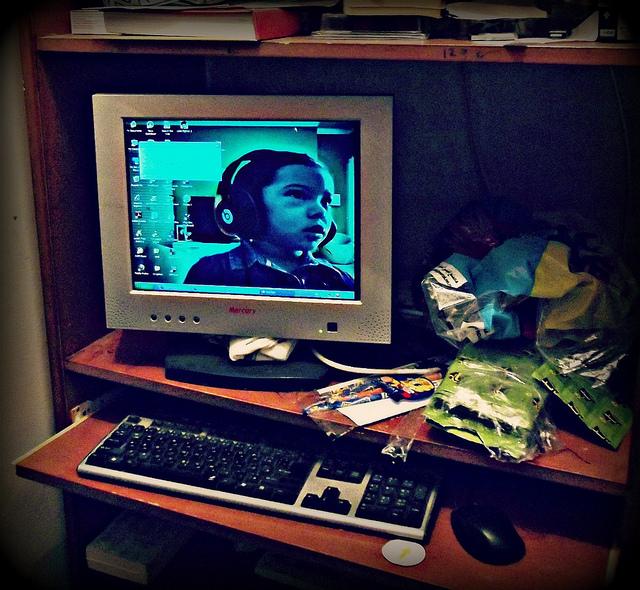What side of the keyboard is the mouse?
Concise answer only. Right. What color is the laptop?
Short answer required. Silver. Is the desk clean?
Quick response, please. No. Are there headphones?
Write a very short answer. Yes. Are there wires showing?
Short answer required. Yes. How many computer screens are there?
Keep it brief. 1. What device is playing a program?
Keep it brief. Computer. 